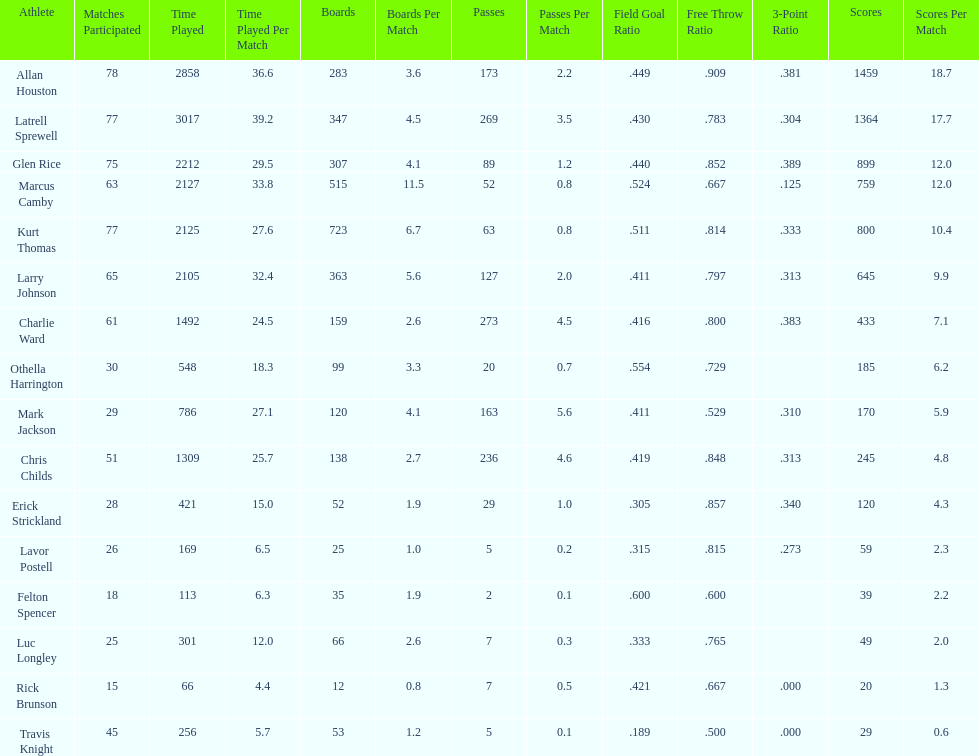How many total points were scored by players averaging over 4 assists per game> 848. 